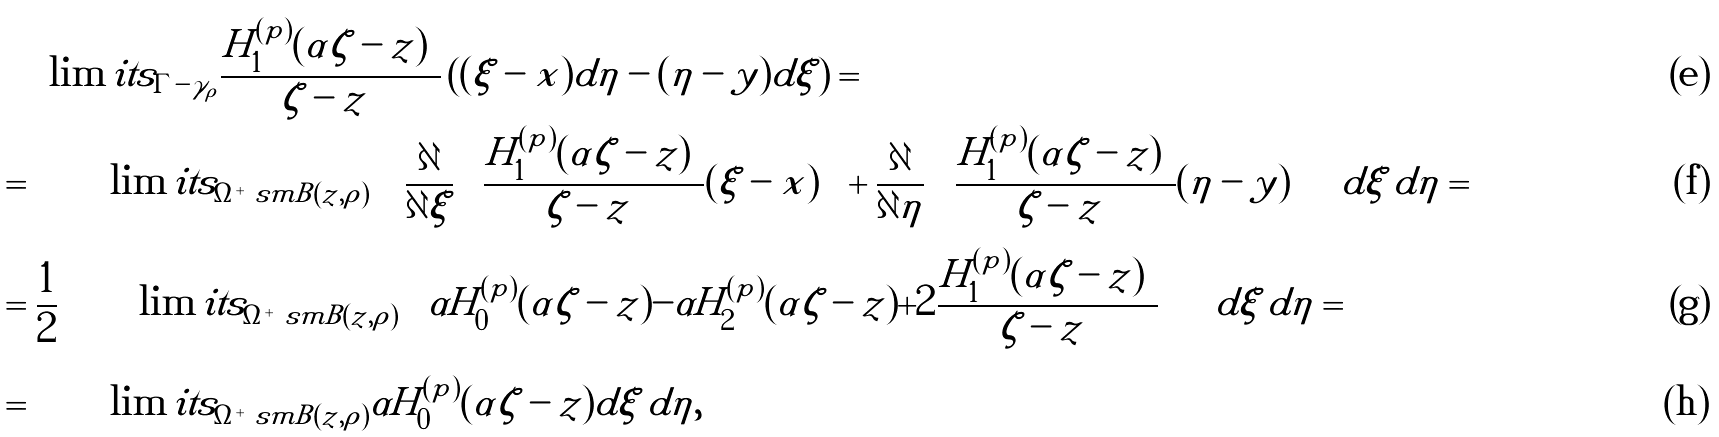<formula> <loc_0><loc_0><loc_500><loc_500>& \int \lim i t s _ { \Gamma - \gamma _ { \rho } } \frac { H _ { 1 } ^ { ( p ) } ( \alpha | \zeta - z | ) } { | \zeta - z | } \left ( ( \xi - x ) d \eta - ( \eta - y ) d \xi \right ) = \\ & = \iint \lim i t s _ { \Omega ^ { + } \ s m B ( z , \rho ) } \, \left ( \frac { \partial } { \partial \xi } \left ( \frac { H _ { 1 } ^ { ( p ) } ( \alpha | \zeta - z | ) } { | \zeta - z | } ( \xi - x ) \right ) + \frac { \partial } { \partial \eta } \left ( \frac { H _ { 1 } ^ { ( p ) } ( \alpha | \zeta - z | ) } { | \zeta - z | } ( \eta - y ) \right ) \right ) d \xi \, d \eta = \\ & = \frac { 1 } { 2 } \iint \lim i t s _ { \Omega ^ { + } \ s m B ( z , \rho ) } \left ( \alpha H _ { 0 } ^ { ( p ) } ( \alpha | \zeta - z | ) - \alpha H _ { 2 } ^ { ( p ) } ( \alpha | \zeta - z | ) + 2 \frac { H _ { 1 } ^ { ( p ) } ( \alpha | \zeta - z | ) } { | \zeta - z | } \right ) d \xi \, d \eta = \\ & = \iint \lim i t s _ { \Omega ^ { + } \ s m B ( z , \rho ) } \alpha H _ { 0 } ^ { ( p ) } ( \alpha | \zeta - z | ) d \xi \, d \eta ,</formula> 